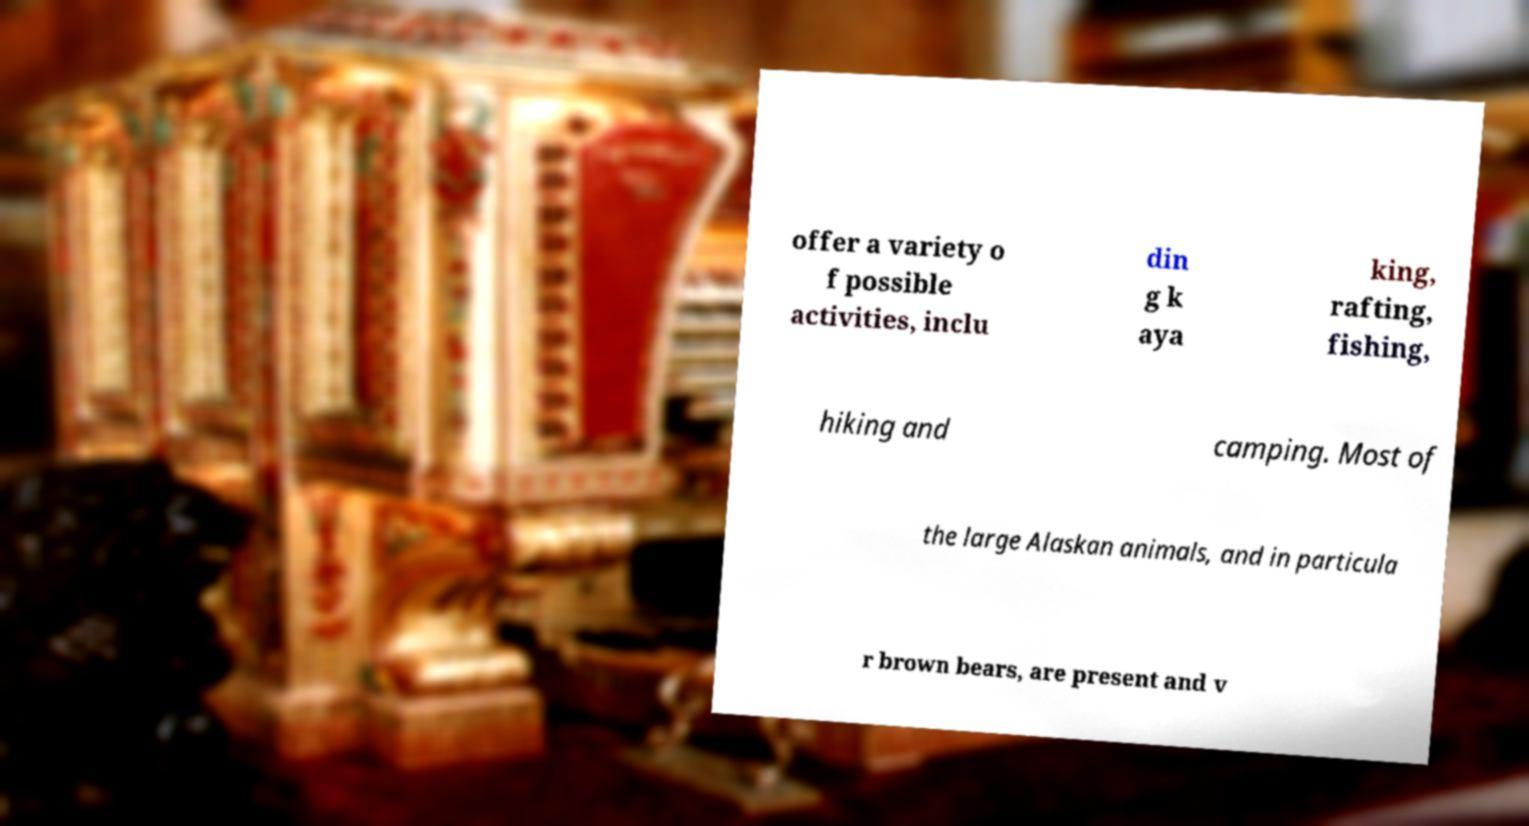Please read and relay the text visible in this image. What does it say? offer a variety o f possible activities, inclu din g k aya king, rafting, fishing, hiking and camping. Most of the large Alaskan animals, and in particula r brown bears, are present and v 